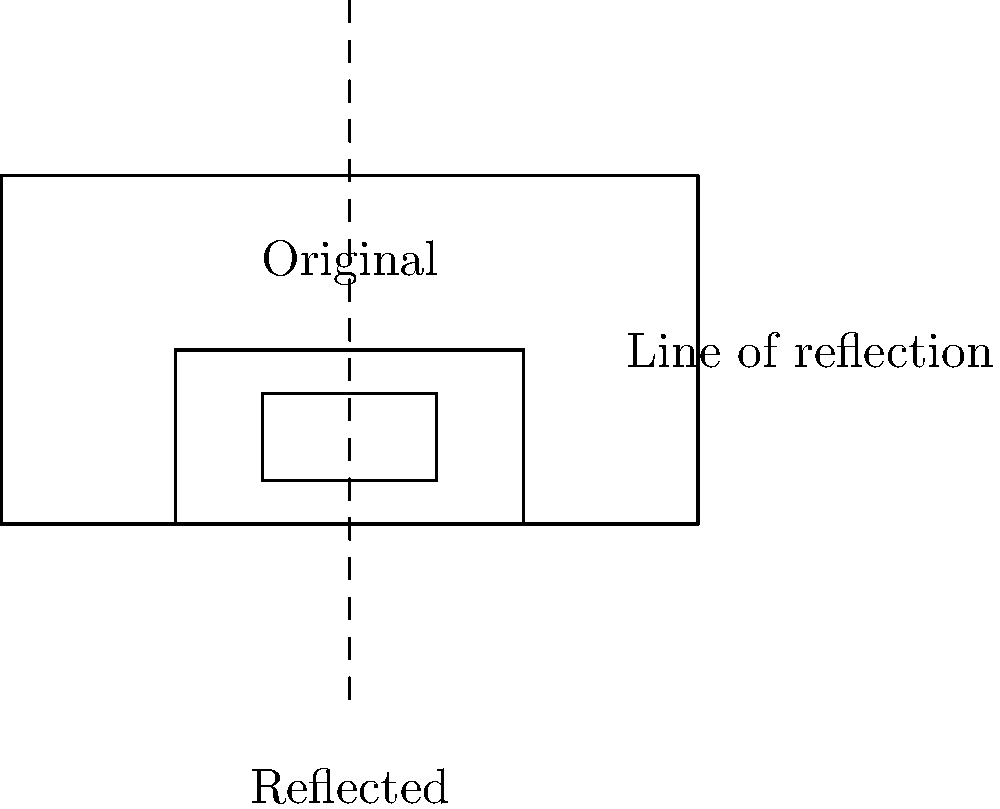Oh snap! Your favorite 90's sitcom marathon just got interrupted by breaking news. To distract yourself, you decide to play with your TV remote. If you reflect the remote across the dashed line shown in the diagram, which of the following statements is true about the reflected image?

A) The reflected remote is smaller than the original
B) The buttons on the reflected remote are on the right side
C) The reflected remote is upside down
D) The reflected remote is the same distance from the line as the original Let's break this down step-by-step:

1) In a reflection, the size and shape of the object remain the same. This eliminates option A.

2) Looking at the original remote, we see the buttons are on the right side. In the reflection:
   - The left side of the remote becomes the right side
   - The right side of the remote becomes the left side
   This means the buttons will be on the left side of the reflected remote, not the right. This eliminates option B.

3) The remote is not flipped upside down. The top of the remote is still at the top, and the bottom is still at the bottom. This eliminates option C.

4) In a reflection, every point of the object is the same distance from the line of reflection as its corresponding point on the reflected image. This is a fundamental property of reflections.

Therefore, the correct answer is D. The reflected remote is the same distance from the line as the original.

This property is why reflections in mirrors appear to be the same distance behind the mirror as you are in front of it!
Answer: D) The reflected remote is the same distance from the line as the original 